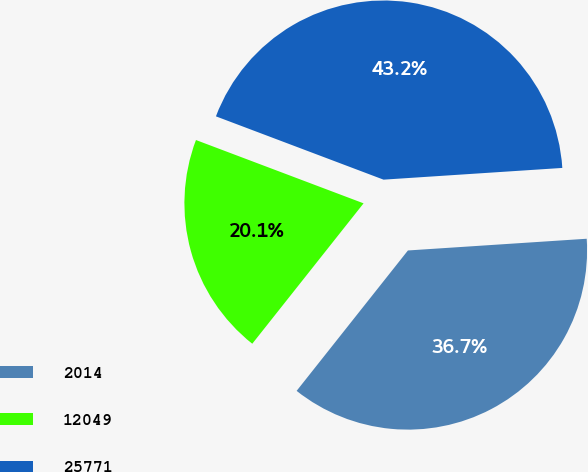Convert chart. <chart><loc_0><loc_0><loc_500><loc_500><pie_chart><fcel>2014<fcel>12049<fcel>25771<nl><fcel>36.71%<fcel>20.08%<fcel>43.21%<nl></chart> 